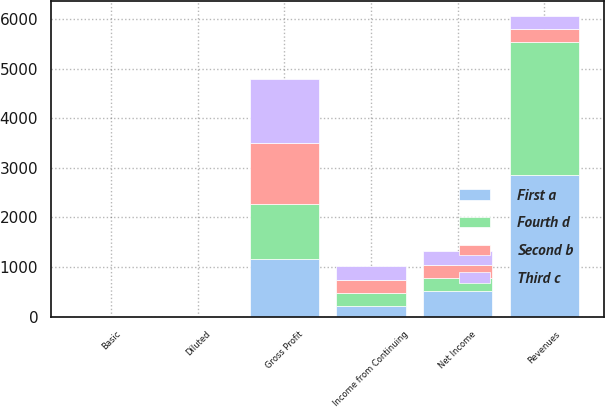Convert chart. <chart><loc_0><loc_0><loc_500><loc_500><stacked_bar_chart><ecel><fcel>Revenues<fcel>Gross Profit<fcel>Income from Continuing<fcel>Net Income<fcel>Basic<fcel>Diluted<nl><fcel>Fourth d<fcel>2682.6<fcel>1116.3<fcel>247.5<fcel>252.2<fcel>0.64<fcel>0.63<nl><fcel>First a<fcel>2854<fcel>1161<fcel>217.1<fcel>523.4<fcel>0.57<fcel>0.56<nl><fcel>Second b<fcel>258.8<fcel>1218.9<fcel>266.3<fcel>265.4<fcel>0.7<fcel>0.7<nl><fcel>Third c<fcel>258.8<fcel>1297.8<fcel>292.5<fcel>288.9<fcel>0.78<fcel>0.78<nl></chart> 